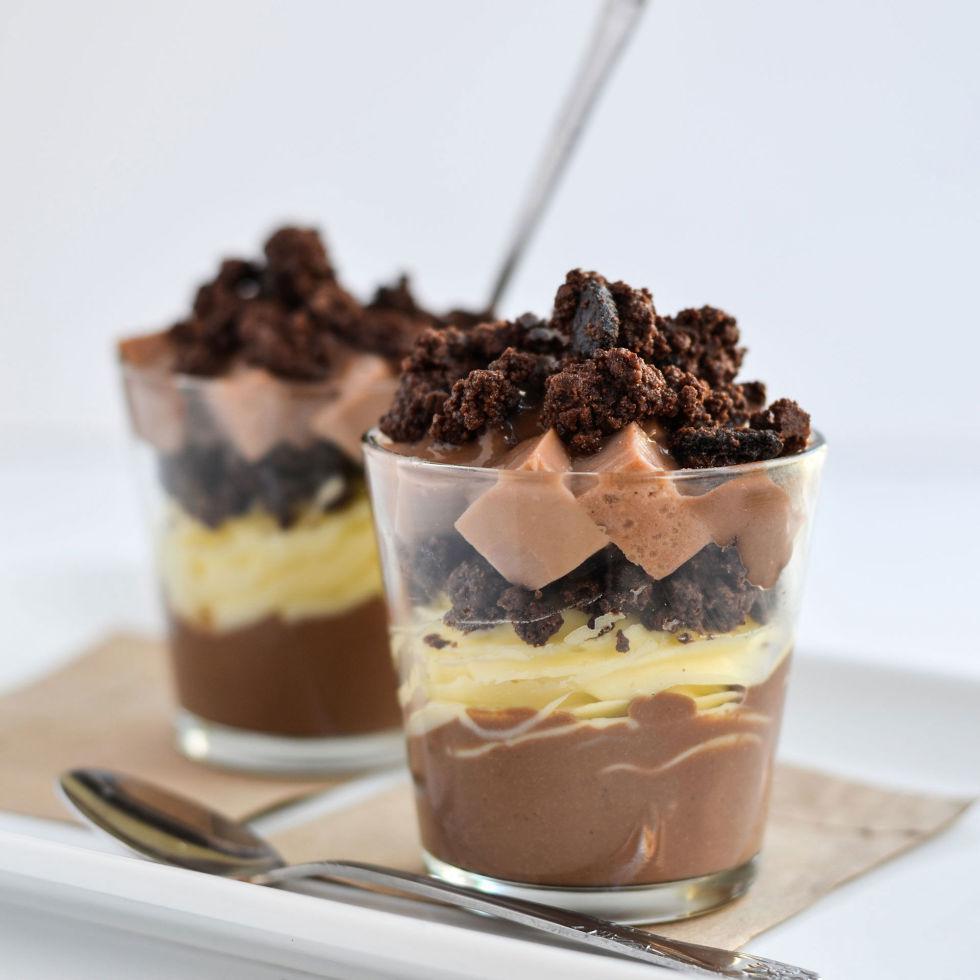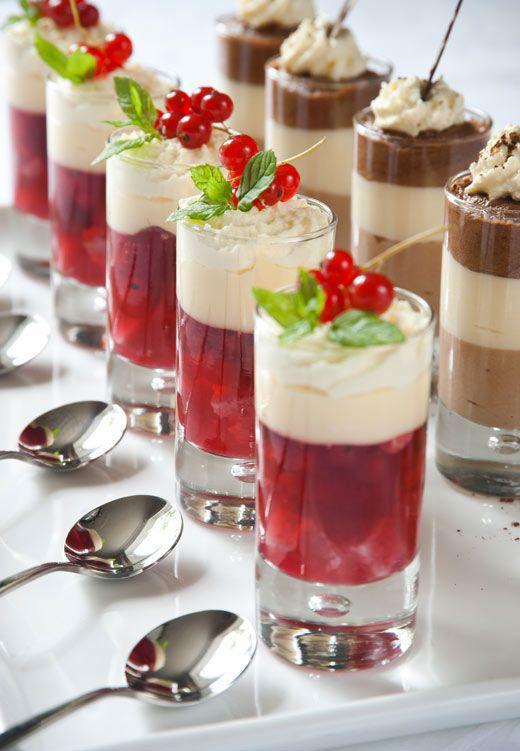The first image is the image on the left, the second image is the image on the right. For the images shown, is this caption "There are treats in the right image that are topped with cherries, but none in the left image." true? Answer yes or no. Yes. The first image is the image on the left, the second image is the image on the right. Given the left and right images, does the statement "the left image contains 2 layered dessert portions" hold true? Answer yes or no. Yes. 